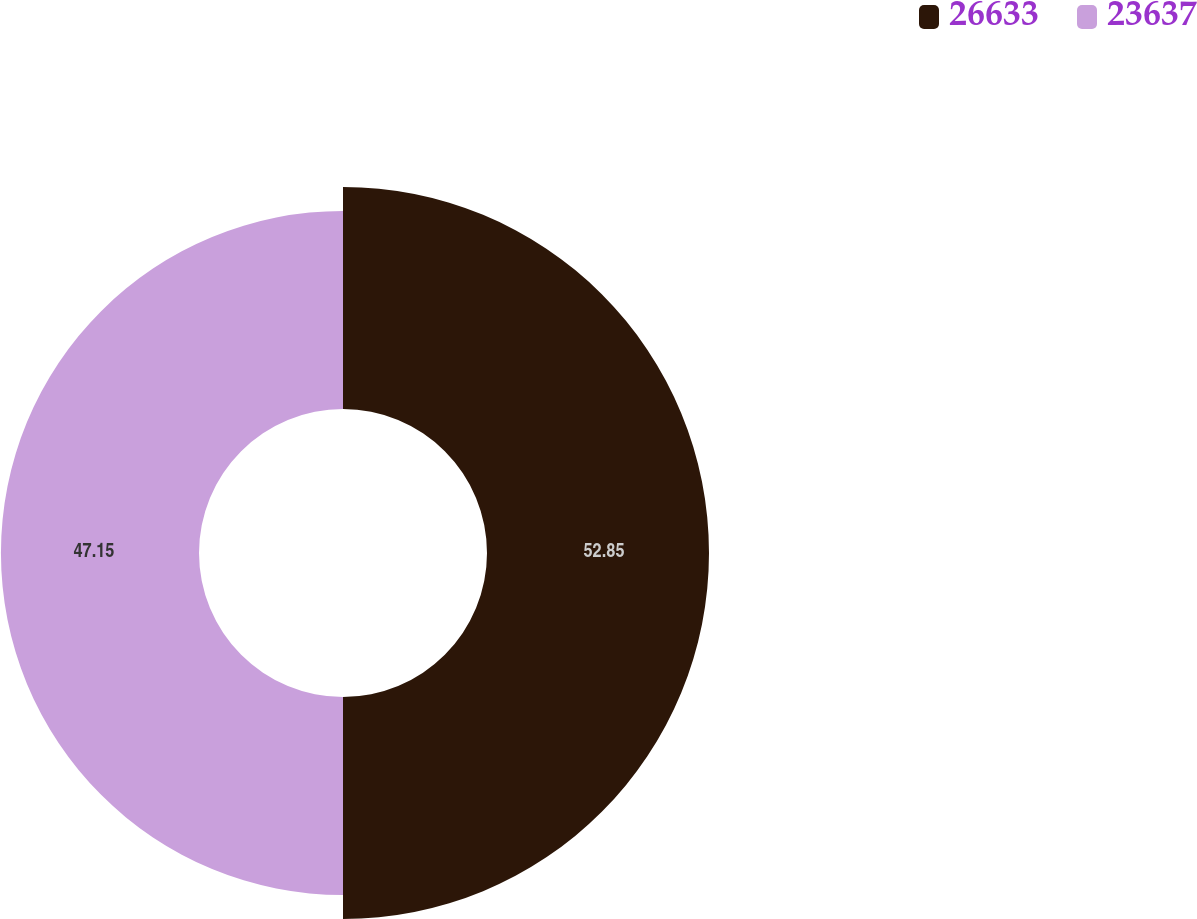Convert chart. <chart><loc_0><loc_0><loc_500><loc_500><pie_chart><fcel>26633<fcel>23637<nl><fcel>52.85%<fcel>47.15%<nl></chart> 